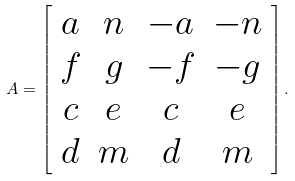<formula> <loc_0><loc_0><loc_500><loc_500>A = \left [ \begin{array} { c c c c } a & n & - a & - n \\ f & g & - f & - g \\ c & e & c & e \\ d & m & d & m \end{array} \right ] .</formula> 